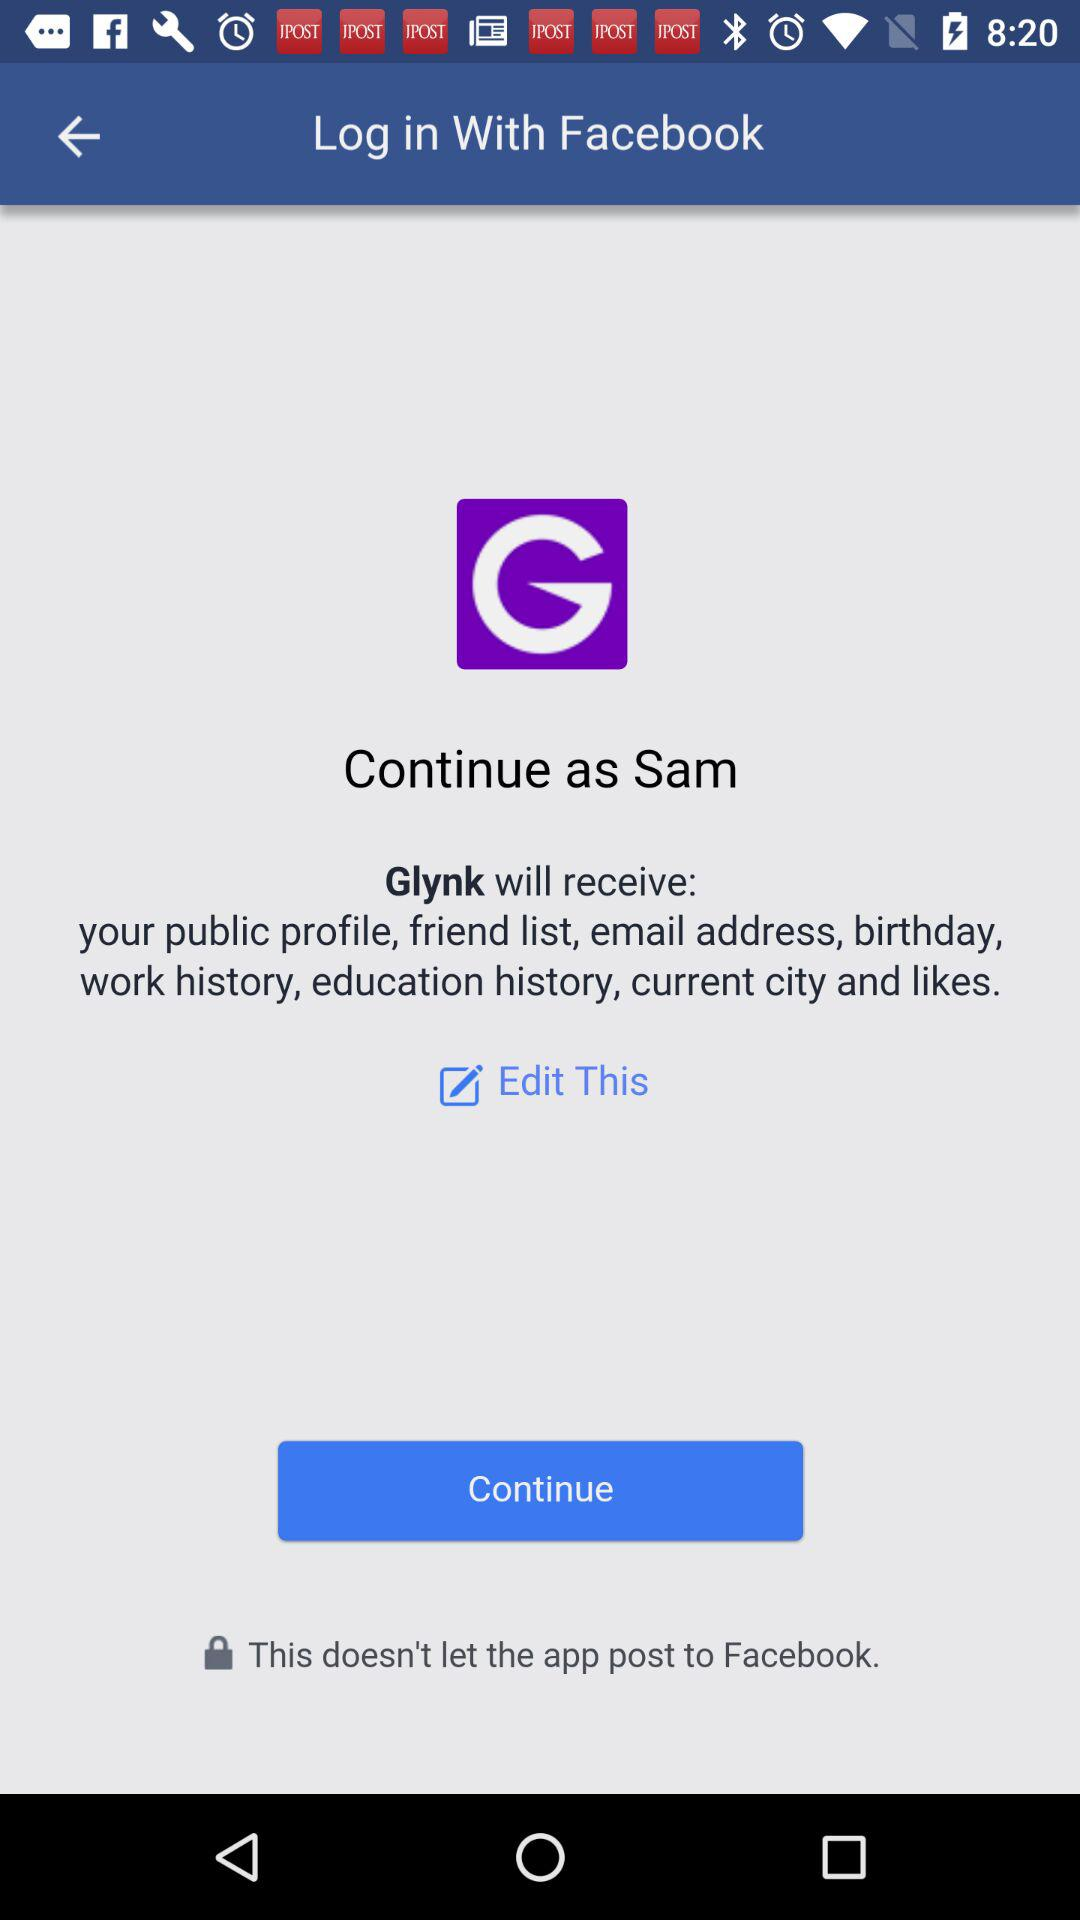What is the name of the user? The name of the user is Sam. 